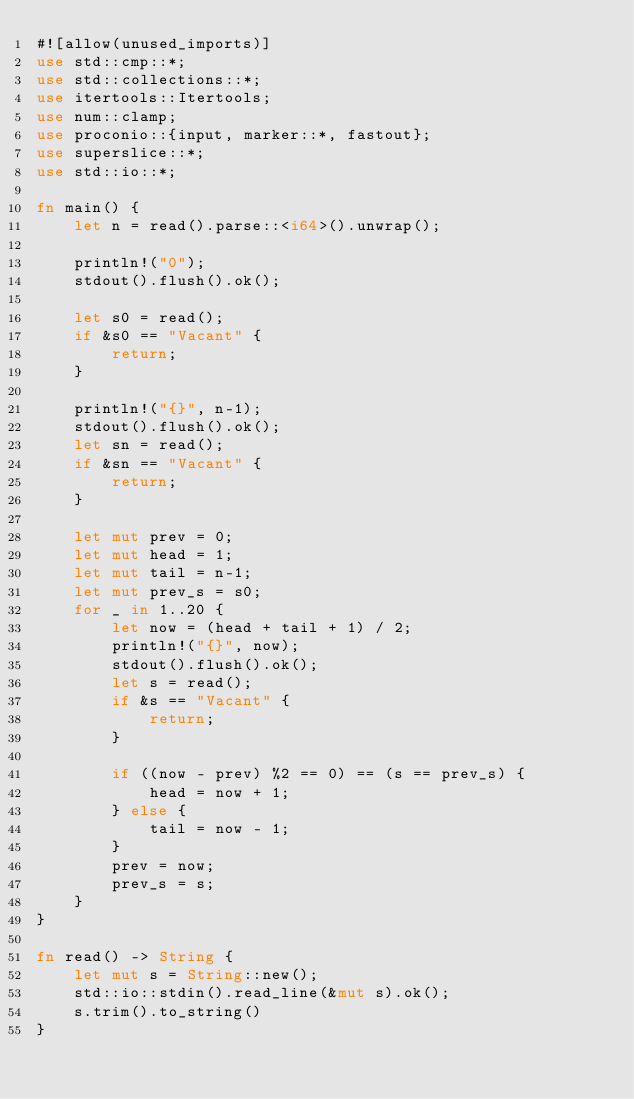Convert code to text. <code><loc_0><loc_0><loc_500><loc_500><_Rust_>#![allow(unused_imports)]
use std::cmp::*;
use std::collections::*;
use itertools::Itertools;
use num::clamp;
use proconio::{input, marker::*, fastout};
use superslice::*;
use std::io::*;

fn main() {
    let n = read().parse::<i64>().unwrap();

    println!("0");
    stdout().flush().ok();

    let s0 = read();
    if &s0 == "Vacant" {
        return;
    }
    
    println!("{}", n-1);
    stdout().flush().ok();
    let sn = read();
    if &sn == "Vacant" {
        return;
    }
    
    let mut prev = 0;
    let mut head = 1;
    let mut tail = n-1;
    let mut prev_s = s0;
    for _ in 1..20 {
        let now = (head + tail + 1) / 2;
        println!("{}", now);
        stdout().flush().ok();
        let s = read();
        if &s == "Vacant" {
            return;
        }

        if ((now - prev) %2 == 0) == (s == prev_s) {
            head = now + 1;
        } else {
            tail = now - 1;
        }
        prev = now;
        prev_s = s;
    }
}

fn read() -> String {
    let mut s = String::new();
    std::io::stdin().read_line(&mut s).ok();
    s.trim().to_string()
}
</code> 